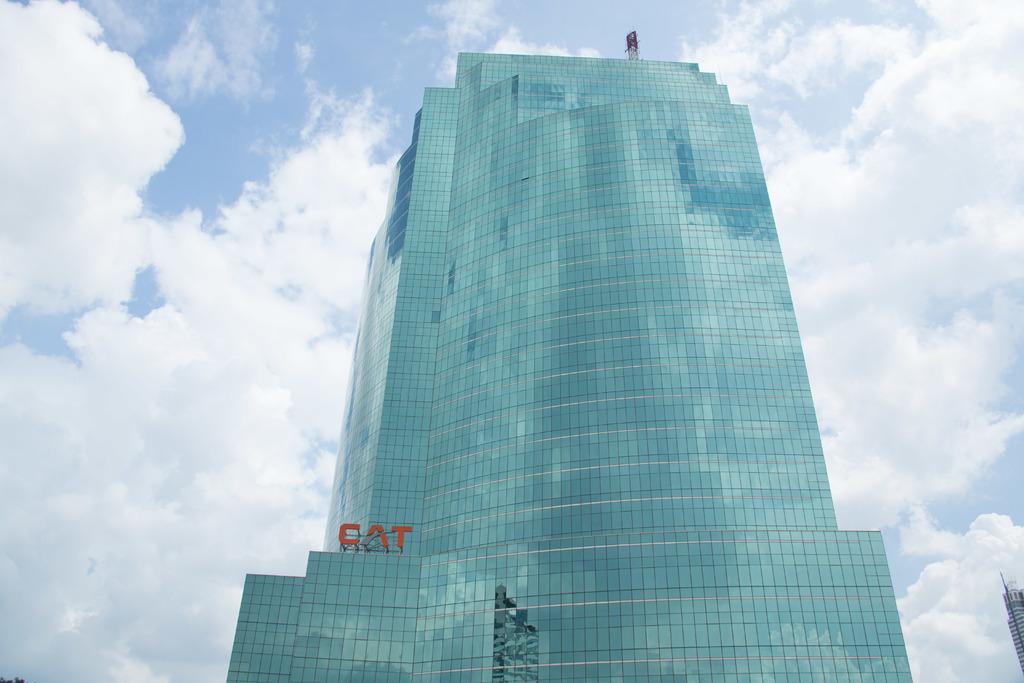What do the red letters say?
Give a very brief answer. Cat. 